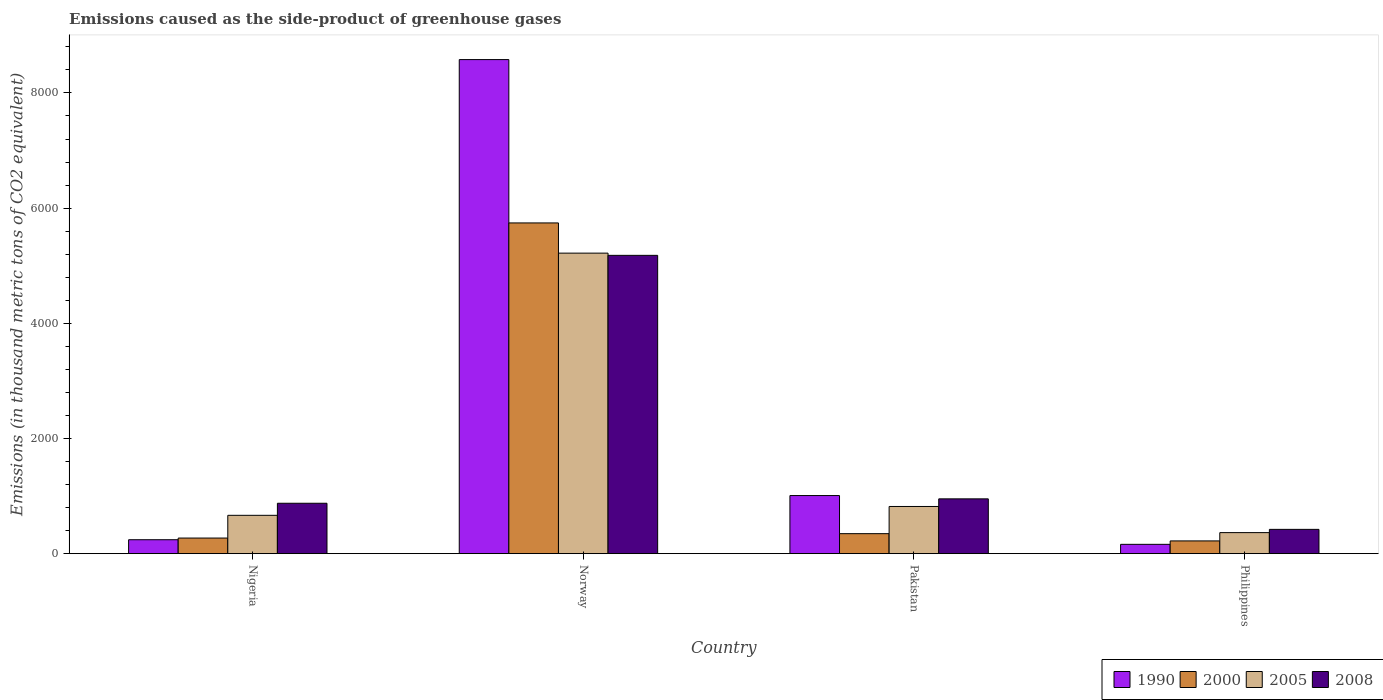Are the number of bars on each tick of the X-axis equal?
Your answer should be compact. Yes. How many bars are there on the 2nd tick from the right?
Offer a terse response. 4. What is the label of the 4th group of bars from the left?
Your answer should be very brief. Philippines. In how many cases, is the number of bars for a given country not equal to the number of legend labels?
Your answer should be compact. 0. What is the emissions caused as the side-product of greenhouse gases in 2000 in Pakistan?
Offer a very short reply. 347.2. Across all countries, what is the maximum emissions caused as the side-product of greenhouse gases in 1990?
Provide a short and direct response. 8579.3. Across all countries, what is the minimum emissions caused as the side-product of greenhouse gases in 2005?
Your response must be concise. 365.3. In which country was the emissions caused as the side-product of greenhouse gases in 1990 maximum?
Keep it short and to the point. Norway. In which country was the emissions caused as the side-product of greenhouse gases in 2000 minimum?
Make the answer very short. Philippines. What is the total emissions caused as the side-product of greenhouse gases in 2005 in the graph?
Offer a very short reply. 7068.9. What is the difference between the emissions caused as the side-product of greenhouse gases in 2005 in Nigeria and that in Philippines?
Give a very brief answer. 300.4. What is the difference between the emissions caused as the side-product of greenhouse gases in 1990 in Pakistan and the emissions caused as the side-product of greenhouse gases in 2008 in Norway?
Offer a very short reply. -4170.9. What is the average emissions caused as the side-product of greenhouse gases in 2005 per country?
Ensure brevity in your answer.  1767.22. What is the difference between the emissions caused as the side-product of greenhouse gases of/in 1990 and emissions caused as the side-product of greenhouse gases of/in 2008 in Norway?
Your response must be concise. 3399.4. What is the ratio of the emissions caused as the side-product of greenhouse gases in 2000 in Norway to that in Pakistan?
Provide a succinct answer. 16.54. Is the emissions caused as the side-product of greenhouse gases in 1990 in Nigeria less than that in Norway?
Give a very brief answer. Yes. What is the difference between the highest and the second highest emissions caused as the side-product of greenhouse gases in 2005?
Provide a short and direct response. -4552.8. What is the difference between the highest and the lowest emissions caused as the side-product of greenhouse gases in 2000?
Offer a very short reply. 5521.4. Is the sum of the emissions caused as the side-product of greenhouse gases in 2005 in Norway and Philippines greater than the maximum emissions caused as the side-product of greenhouse gases in 2008 across all countries?
Provide a succinct answer. Yes. How many bars are there?
Make the answer very short. 16. Are all the bars in the graph horizontal?
Keep it short and to the point. No. What is the difference between two consecutive major ticks on the Y-axis?
Give a very brief answer. 2000. Does the graph contain any zero values?
Make the answer very short. No. Where does the legend appear in the graph?
Your response must be concise. Bottom right. How many legend labels are there?
Provide a short and direct response. 4. What is the title of the graph?
Offer a very short reply. Emissions caused as the side-product of greenhouse gases. Does "1973" appear as one of the legend labels in the graph?
Offer a terse response. No. What is the label or title of the Y-axis?
Make the answer very short. Emissions (in thousand metric tons of CO2 equivalent). What is the Emissions (in thousand metric tons of CO2 equivalent) in 1990 in Nigeria?
Your response must be concise. 241.9. What is the Emissions (in thousand metric tons of CO2 equivalent) of 2000 in Nigeria?
Give a very brief answer. 270.9. What is the Emissions (in thousand metric tons of CO2 equivalent) of 2005 in Nigeria?
Provide a short and direct response. 665.7. What is the Emissions (in thousand metric tons of CO2 equivalent) in 2008 in Nigeria?
Your response must be concise. 875.2. What is the Emissions (in thousand metric tons of CO2 equivalent) of 1990 in Norway?
Offer a very short reply. 8579.3. What is the Emissions (in thousand metric tons of CO2 equivalent) in 2000 in Norway?
Ensure brevity in your answer.  5742.8. What is the Emissions (in thousand metric tons of CO2 equivalent) in 2005 in Norway?
Offer a very short reply. 5218.5. What is the Emissions (in thousand metric tons of CO2 equivalent) of 2008 in Norway?
Make the answer very short. 5179.9. What is the Emissions (in thousand metric tons of CO2 equivalent) in 1990 in Pakistan?
Make the answer very short. 1009. What is the Emissions (in thousand metric tons of CO2 equivalent) of 2000 in Pakistan?
Your answer should be very brief. 347.2. What is the Emissions (in thousand metric tons of CO2 equivalent) of 2005 in Pakistan?
Your answer should be compact. 819.4. What is the Emissions (in thousand metric tons of CO2 equivalent) of 2008 in Pakistan?
Provide a short and direct response. 951.6. What is the Emissions (in thousand metric tons of CO2 equivalent) in 1990 in Philippines?
Give a very brief answer. 161.9. What is the Emissions (in thousand metric tons of CO2 equivalent) in 2000 in Philippines?
Your answer should be very brief. 221.4. What is the Emissions (in thousand metric tons of CO2 equivalent) in 2005 in Philippines?
Your answer should be compact. 365.3. What is the Emissions (in thousand metric tons of CO2 equivalent) of 2008 in Philippines?
Offer a terse response. 421.7. Across all countries, what is the maximum Emissions (in thousand metric tons of CO2 equivalent) of 1990?
Provide a short and direct response. 8579.3. Across all countries, what is the maximum Emissions (in thousand metric tons of CO2 equivalent) in 2000?
Your response must be concise. 5742.8. Across all countries, what is the maximum Emissions (in thousand metric tons of CO2 equivalent) of 2005?
Your answer should be very brief. 5218.5. Across all countries, what is the maximum Emissions (in thousand metric tons of CO2 equivalent) in 2008?
Offer a terse response. 5179.9. Across all countries, what is the minimum Emissions (in thousand metric tons of CO2 equivalent) of 1990?
Give a very brief answer. 161.9. Across all countries, what is the minimum Emissions (in thousand metric tons of CO2 equivalent) in 2000?
Provide a succinct answer. 221.4. Across all countries, what is the minimum Emissions (in thousand metric tons of CO2 equivalent) of 2005?
Provide a succinct answer. 365.3. Across all countries, what is the minimum Emissions (in thousand metric tons of CO2 equivalent) in 2008?
Your answer should be compact. 421.7. What is the total Emissions (in thousand metric tons of CO2 equivalent) in 1990 in the graph?
Your response must be concise. 9992.1. What is the total Emissions (in thousand metric tons of CO2 equivalent) in 2000 in the graph?
Give a very brief answer. 6582.3. What is the total Emissions (in thousand metric tons of CO2 equivalent) of 2005 in the graph?
Provide a short and direct response. 7068.9. What is the total Emissions (in thousand metric tons of CO2 equivalent) of 2008 in the graph?
Your answer should be compact. 7428.4. What is the difference between the Emissions (in thousand metric tons of CO2 equivalent) in 1990 in Nigeria and that in Norway?
Provide a short and direct response. -8337.4. What is the difference between the Emissions (in thousand metric tons of CO2 equivalent) of 2000 in Nigeria and that in Norway?
Your answer should be very brief. -5471.9. What is the difference between the Emissions (in thousand metric tons of CO2 equivalent) in 2005 in Nigeria and that in Norway?
Your answer should be compact. -4552.8. What is the difference between the Emissions (in thousand metric tons of CO2 equivalent) of 2008 in Nigeria and that in Norway?
Provide a succinct answer. -4304.7. What is the difference between the Emissions (in thousand metric tons of CO2 equivalent) of 1990 in Nigeria and that in Pakistan?
Keep it short and to the point. -767.1. What is the difference between the Emissions (in thousand metric tons of CO2 equivalent) of 2000 in Nigeria and that in Pakistan?
Provide a short and direct response. -76.3. What is the difference between the Emissions (in thousand metric tons of CO2 equivalent) in 2005 in Nigeria and that in Pakistan?
Make the answer very short. -153.7. What is the difference between the Emissions (in thousand metric tons of CO2 equivalent) of 2008 in Nigeria and that in Pakistan?
Offer a terse response. -76.4. What is the difference between the Emissions (in thousand metric tons of CO2 equivalent) in 2000 in Nigeria and that in Philippines?
Offer a terse response. 49.5. What is the difference between the Emissions (in thousand metric tons of CO2 equivalent) of 2005 in Nigeria and that in Philippines?
Ensure brevity in your answer.  300.4. What is the difference between the Emissions (in thousand metric tons of CO2 equivalent) in 2008 in Nigeria and that in Philippines?
Your answer should be compact. 453.5. What is the difference between the Emissions (in thousand metric tons of CO2 equivalent) of 1990 in Norway and that in Pakistan?
Keep it short and to the point. 7570.3. What is the difference between the Emissions (in thousand metric tons of CO2 equivalent) of 2000 in Norway and that in Pakistan?
Give a very brief answer. 5395.6. What is the difference between the Emissions (in thousand metric tons of CO2 equivalent) of 2005 in Norway and that in Pakistan?
Provide a succinct answer. 4399.1. What is the difference between the Emissions (in thousand metric tons of CO2 equivalent) in 2008 in Norway and that in Pakistan?
Offer a very short reply. 4228.3. What is the difference between the Emissions (in thousand metric tons of CO2 equivalent) of 1990 in Norway and that in Philippines?
Keep it short and to the point. 8417.4. What is the difference between the Emissions (in thousand metric tons of CO2 equivalent) in 2000 in Norway and that in Philippines?
Give a very brief answer. 5521.4. What is the difference between the Emissions (in thousand metric tons of CO2 equivalent) of 2005 in Norway and that in Philippines?
Give a very brief answer. 4853.2. What is the difference between the Emissions (in thousand metric tons of CO2 equivalent) of 2008 in Norway and that in Philippines?
Make the answer very short. 4758.2. What is the difference between the Emissions (in thousand metric tons of CO2 equivalent) in 1990 in Pakistan and that in Philippines?
Give a very brief answer. 847.1. What is the difference between the Emissions (in thousand metric tons of CO2 equivalent) of 2000 in Pakistan and that in Philippines?
Offer a terse response. 125.8. What is the difference between the Emissions (in thousand metric tons of CO2 equivalent) of 2005 in Pakistan and that in Philippines?
Give a very brief answer. 454.1. What is the difference between the Emissions (in thousand metric tons of CO2 equivalent) in 2008 in Pakistan and that in Philippines?
Your answer should be very brief. 529.9. What is the difference between the Emissions (in thousand metric tons of CO2 equivalent) in 1990 in Nigeria and the Emissions (in thousand metric tons of CO2 equivalent) in 2000 in Norway?
Offer a very short reply. -5500.9. What is the difference between the Emissions (in thousand metric tons of CO2 equivalent) of 1990 in Nigeria and the Emissions (in thousand metric tons of CO2 equivalent) of 2005 in Norway?
Keep it short and to the point. -4976.6. What is the difference between the Emissions (in thousand metric tons of CO2 equivalent) of 1990 in Nigeria and the Emissions (in thousand metric tons of CO2 equivalent) of 2008 in Norway?
Offer a terse response. -4938. What is the difference between the Emissions (in thousand metric tons of CO2 equivalent) of 2000 in Nigeria and the Emissions (in thousand metric tons of CO2 equivalent) of 2005 in Norway?
Offer a very short reply. -4947.6. What is the difference between the Emissions (in thousand metric tons of CO2 equivalent) of 2000 in Nigeria and the Emissions (in thousand metric tons of CO2 equivalent) of 2008 in Norway?
Give a very brief answer. -4909. What is the difference between the Emissions (in thousand metric tons of CO2 equivalent) of 2005 in Nigeria and the Emissions (in thousand metric tons of CO2 equivalent) of 2008 in Norway?
Keep it short and to the point. -4514.2. What is the difference between the Emissions (in thousand metric tons of CO2 equivalent) in 1990 in Nigeria and the Emissions (in thousand metric tons of CO2 equivalent) in 2000 in Pakistan?
Make the answer very short. -105.3. What is the difference between the Emissions (in thousand metric tons of CO2 equivalent) of 1990 in Nigeria and the Emissions (in thousand metric tons of CO2 equivalent) of 2005 in Pakistan?
Keep it short and to the point. -577.5. What is the difference between the Emissions (in thousand metric tons of CO2 equivalent) of 1990 in Nigeria and the Emissions (in thousand metric tons of CO2 equivalent) of 2008 in Pakistan?
Provide a short and direct response. -709.7. What is the difference between the Emissions (in thousand metric tons of CO2 equivalent) of 2000 in Nigeria and the Emissions (in thousand metric tons of CO2 equivalent) of 2005 in Pakistan?
Make the answer very short. -548.5. What is the difference between the Emissions (in thousand metric tons of CO2 equivalent) in 2000 in Nigeria and the Emissions (in thousand metric tons of CO2 equivalent) in 2008 in Pakistan?
Provide a succinct answer. -680.7. What is the difference between the Emissions (in thousand metric tons of CO2 equivalent) in 2005 in Nigeria and the Emissions (in thousand metric tons of CO2 equivalent) in 2008 in Pakistan?
Your response must be concise. -285.9. What is the difference between the Emissions (in thousand metric tons of CO2 equivalent) of 1990 in Nigeria and the Emissions (in thousand metric tons of CO2 equivalent) of 2000 in Philippines?
Provide a short and direct response. 20.5. What is the difference between the Emissions (in thousand metric tons of CO2 equivalent) in 1990 in Nigeria and the Emissions (in thousand metric tons of CO2 equivalent) in 2005 in Philippines?
Your answer should be compact. -123.4. What is the difference between the Emissions (in thousand metric tons of CO2 equivalent) in 1990 in Nigeria and the Emissions (in thousand metric tons of CO2 equivalent) in 2008 in Philippines?
Make the answer very short. -179.8. What is the difference between the Emissions (in thousand metric tons of CO2 equivalent) in 2000 in Nigeria and the Emissions (in thousand metric tons of CO2 equivalent) in 2005 in Philippines?
Give a very brief answer. -94.4. What is the difference between the Emissions (in thousand metric tons of CO2 equivalent) in 2000 in Nigeria and the Emissions (in thousand metric tons of CO2 equivalent) in 2008 in Philippines?
Provide a succinct answer. -150.8. What is the difference between the Emissions (in thousand metric tons of CO2 equivalent) in 2005 in Nigeria and the Emissions (in thousand metric tons of CO2 equivalent) in 2008 in Philippines?
Ensure brevity in your answer.  244. What is the difference between the Emissions (in thousand metric tons of CO2 equivalent) of 1990 in Norway and the Emissions (in thousand metric tons of CO2 equivalent) of 2000 in Pakistan?
Your response must be concise. 8232.1. What is the difference between the Emissions (in thousand metric tons of CO2 equivalent) in 1990 in Norway and the Emissions (in thousand metric tons of CO2 equivalent) in 2005 in Pakistan?
Give a very brief answer. 7759.9. What is the difference between the Emissions (in thousand metric tons of CO2 equivalent) of 1990 in Norway and the Emissions (in thousand metric tons of CO2 equivalent) of 2008 in Pakistan?
Keep it short and to the point. 7627.7. What is the difference between the Emissions (in thousand metric tons of CO2 equivalent) of 2000 in Norway and the Emissions (in thousand metric tons of CO2 equivalent) of 2005 in Pakistan?
Your answer should be compact. 4923.4. What is the difference between the Emissions (in thousand metric tons of CO2 equivalent) in 2000 in Norway and the Emissions (in thousand metric tons of CO2 equivalent) in 2008 in Pakistan?
Offer a very short reply. 4791.2. What is the difference between the Emissions (in thousand metric tons of CO2 equivalent) in 2005 in Norway and the Emissions (in thousand metric tons of CO2 equivalent) in 2008 in Pakistan?
Ensure brevity in your answer.  4266.9. What is the difference between the Emissions (in thousand metric tons of CO2 equivalent) in 1990 in Norway and the Emissions (in thousand metric tons of CO2 equivalent) in 2000 in Philippines?
Your response must be concise. 8357.9. What is the difference between the Emissions (in thousand metric tons of CO2 equivalent) of 1990 in Norway and the Emissions (in thousand metric tons of CO2 equivalent) of 2005 in Philippines?
Give a very brief answer. 8214. What is the difference between the Emissions (in thousand metric tons of CO2 equivalent) in 1990 in Norway and the Emissions (in thousand metric tons of CO2 equivalent) in 2008 in Philippines?
Your answer should be compact. 8157.6. What is the difference between the Emissions (in thousand metric tons of CO2 equivalent) of 2000 in Norway and the Emissions (in thousand metric tons of CO2 equivalent) of 2005 in Philippines?
Your answer should be very brief. 5377.5. What is the difference between the Emissions (in thousand metric tons of CO2 equivalent) in 2000 in Norway and the Emissions (in thousand metric tons of CO2 equivalent) in 2008 in Philippines?
Keep it short and to the point. 5321.1. What is the difference between the Emissions (in thousand metric tons of CO2 equivalent) of 2005 in Norway and the Emissions (in thousand metric tons of CO2 equivalent) of 2008 in Philippines?
Ensure brevity in your answer.  4796.8. What is the difference between the Emissions (in thousand metric tons of CO2 equivalent) of 1990 in Pakistan and the Emissions (in thousand metric tons of CO2 equivalent) of 2000 in Philippines?
Offer a very short reply. 787.6. What is the difference between the Emissions (in thousand metric tons of CO2 equivalent) in 1990 in Pakistan and the Emissions (in thousand metric tons of CO2 equivalent) in 2005 in Philippines?
Your response must be concise. 643.7. What is the difference between the Emissions (in thousand metric tons of CO2 equivalent) of 1990 in Pakistan and the Emissions (in thousand metric tons of CO2 equivalent) of 2008 in Philippines?
Your answer should be very brief. 587.3. What is the difference between the Emissions (in thousand metric tons of CO2 equivalent) in 2000 in Pakistan and the Emissions (in thousand metric tons of CO2 equivalent) in 2005 in Philippines?
Give a very brief answer. -18.1. What is the difference between the Emissions (in thousand metric tons of CO2 equivalent) in 2000 in Pakistan and the Emissions (in thousand metric tons of CO2 equivalent) in 2008 in Philippines?
Your response must be concise. -74.5. What is the difference between the Emissions (in thousand metric tons of CO2 equivalent) in 2005 in Pakistan and the Emissions (in thousand metric tons of CO2 equivalent) in 2008 in Philippines?
Offer a terse response. 397.7. What is the average Emissions (in thousand metric tons of CO2 equivalent) in 1990 per country?
Ensure brevity in your answer.  2498.03. What is the average Emissions (in thousand metric tons of CO2 equivalent) of 2000 per country?
Offer a terse response. 1645.58. What is the average Emissions (in thousand metric tons of CO2 equivalent) in 2005 per country?
Make the answer very short. 1767.22. What is the average Emissions (in thousand metric tons of CO2 equivalent) in 2008 per country?
Your answer should be compact. 1857.1. What is the difference between the Emissions (in thousand metric tons of CO2 equivalent) in 1990 and Emissions (in thousand metric tons of CO2 equivalent) in 2005 in Nigeria?
Provide a succinct answer. -423.8. What is the difference between the Emissions (in thousand metric tons of CO2 equivalent) in 1990 and Emissions (in thousand metric tons of CO2 equivalent) in 2008 in Nigeria?
Make the answer very short. -633.3. What is the difference between the Emissions (in thousand metric tons of CO2 equivalent) of 2000 and Emissions (in thousand metric tons of CO2 equivalent) of 2005 in Nigeria?
Your answer should be compact. -394.8. What is the difference between the Emissions (in thousand metric tons of CO2 equivalent) of 2000 and Emissions (in thousand metric tons of CO2 equivalent) of 2008 in Nigeria?
Offer a terse response. -604.3. What is the difference between the Emissions (in thousand metric tons of CO2 equivalent) of 2005 and Emissions (in thousand metric tons of CO2 equivalent) of 2008 in Nigeria?
Give a very brief answer. -209.5. What is the difference between the Emissions (in thousand metric tons of CO2 equivalent) of 1990 and Emissions (in thousand metric tons of CO2 equivalent) of 2000 in Norway?
Give a very brief answer. 2836.5. What is the difference between the Emissions (in thousand metric tons of CO2 equivalent) in 1990 and Emissions (in thousand metric tons of CO2 equivalent) in 2005 in Norway?
Offer a terse response. 3360.8. What is the difference between the Emissions (in thousand metric tons of CO2 equivalent) in 1990 and Emissions (in thousand metric tons of CO2 equivalent) in 2008 in Norway?
Offer a very short reply. 3399.4. What is the difference between the Emissions (in thousand metric tons of CO2 equivalent) in 2000 and Emissions (in thousand metric tons of CO2 equivalent) in 2005 in Norway?
Your answer should be very brief. 524.3. What is the difference between the Emissions (in thousand metric tons of CO2 equivalent) in 2000 and Emissions (in thousand metric tons of CO2 equivalent) in 2008 in Norway?
Your answer should be very brief. 562.9. What is the difference between the Emissions (in thousand metric tons of CO2 equivalent) of 2005 and Emissions (in thousand metric tons of CO2 equivalent) of 2008 in Norway?
Offer a terse response. 38.6. What is the difference between the Emissions (in thousand metric tons of CO2 equivalent) in 1990 and Emissions (in thousand metric tons of CO2 equivalent) in 2000 in Pakistan?
Your answer should be very brief. 661.8. What is the difference between the Emissions (in thousand metric tons of CO2 equivalent) of 1990 and Emissions (in thousand metric tons of CO2 equivalent) of 2005 in Pakistan?
Make the answer very short. 189.6. What is the difference between the Emissions (in thousand metric tons of CO2 equivalent) of 1990 and Emissions (in thousand metric tons of CO2 equivalent) of 2008 in Pakistan?
Offer a very short reply. 57.4. What is the difference between the Emissions (in thousand metric tons of CO2 equivalent) of 2000 and Emissions (in thousand metric tons of CO2 equivalent) of 2005 in Pakistan?
Provide a succinct answer. -472.2. What is the difference between the Emissions (in thousand metric tons of CO2 equivalent) in 2000 and Emissions (in thousand metric tons of CO2 equivalent) in 2008 in Pakistan?
Offer a very short reply. -604.4. What is the difference between the Emissions (in thousand metric tons of CO2 equivalent) of 2005 and Emissions (in thousand metric tons of CO2 equivalent) of 2008 in Pakistan?
Your response must be concise. -132.2. What is the difference between the Emissions (in thousand metric tons of CO2 equivalent) of 1990 and Emissions (in thousand metric tons of CO2 equivalent) of 2000 in Philippines?
Ensure brevity in your answer.  -59.5. What is the difference between the Emissions (in thousand metric tons of CO2 equivalent) in 1990 and Emissions (in thousand metric tons of CO2 equivalent) in 2005 in Philippines?
Offer a very short reply. -203.4. What is the difference between the Emissions (in thousand metric tons of CO2 equivalent) of 1990 and Emissions (in thousand metric tons of CO2 equivalent) of 2008 in Philippines?
Ensure brevity in your answer.  -259.8. What is the difference between the Emissions (in thousand metric tons of CO2 equivalent) of 2000 and Emissions (in thousand metric tons of CO2 equivalent) of 2005 in Philippines?
Make the answer very short. -143.9. What is the difference between the Emissions (in thousand metric tons of CO2 equivalent) of 2000 and Emissions (in thousand metric tons of CO2 equivalent) of 2008 in Philippines?
Offer a terse response. -200.3. What is the difference between the Emissions (in thousand metric tons of CO2 equivalent) in 2005 and Emissions (in thousand metric tons of CO2 equivalent) in 2008 in Philippines?
Keep it short and to the point. -56.4. What is the ratio of the Emissions (in thousand metric tons of CO2 equivalent) of 1990 in Nigeria to that in Norway?
Your answer should be compact. 0.03. What is the ratio of the Emissions (in thousand metric tons of CO2 equivalent) in 2000 in Nigeria to that in Norway?
Your answer should be compact. 0.05. What is the ratio of the Emissions (in thousand metric tons of CO2 equivalent) of 2005 in Nigeria to that in Norway?
Your response must be concise. 0.13. What is the ratio of the Emissions (in thousand metric tons of CO2 equivalent) of 2008 in Nigeria to that in Norway?
Offer a very short reply. 0.17. What is the ratio of the Emissions (in thousand metric tons of CO2 equivalent) of 1990 in Nigeria to that in Pakistan?
Offer a terse response. 0.24. What is the ratio of the Emissions (in thousand metric tons of CO2 equivalent) in 2000 in Nigeria to that in Pakistan?
Your answer should be very brief. 0.78. What is the ratio of the Emissions (in thousand metric tons of CO2 equivalent) in 2005 in Nigeria to that in Pakistan?
Your answer should be very brief. 0.81. What is the ratio of the Emissions (in thousand metric tons of CO2 equivalent) in 2008 in Nigeria to that in Pakistan?
Give a very brief answer. 0.92. What is the ratio of the Emissions (in thousand metric tons of CO2 equivalent) in 1990 in Nigeria to that in Philippines?
Provide a succinct answer. 1.49. What is the ratio of the Emissions (in thousand metric tons of CO2 equivalent) of 2000 in Nigeria to that in Philippines?
Make the answer very short. 1.22. What is the ratio of the Emissions (in thousand metric tons of CO2 equivalent) of 2005 in Nigeria to that in Philippines?
Your answer should be very brief. 1.82. What is the ratio of the Emissions (in thousand metric tons of CO2 equivalent) in 2008 in Nigeria to that in Philippines?
Your answer should be compact. 2.08. What is the ratio of the Emissions (in thousand metric tons of CO2 equivalent) of 1990 in Norway to that in Pakistan?
Give a very brief answer. 8.5. What is the ratio of the Emissions (in thousand metric tons of CO2 equivalent) of 2000 in Norway to that in Pakistan?
Your answer should be very brief. 16.54. What is the ratio of the Emissions (in thousand metric tons of CO2 equivalent) of 2005 in Norway to that in Pakistan?
Give a very brief answer. 6.37. What is the ratio of the Emissions (in thousand metric tons of CO2 equivalent) of 2008 in Norway to that in Pakistan?
Your answer should be very brief. 5.44. What is the ratio of the Emissions (in thousand metric tons of CO2 equivalent) in 1990 in Norway to that in Philippines?
Offer a very short reply. 52.99. What is the ratio of the Emissions (in thousand metric tons of CO2 equivalent) of 2000 in Norway to that in Philippines?
Give a very brief answer. 25.94. What is the ratio of the Emissions (in thousand metric tons of CO2 equivalent) of 2005 in Norway to that in Philippines?
Provide a short and direct response. 14.29. What is the ratio of the Emissions (in thousand metric tons of CO2 equivalent) of 2008 in Norway to that in Philippines?
Make the answer very short. 12.28. What is the ratio of the Emissions (in thousand metric tons of CO2 equivalent) in 1990 in Pakistan to that in Philippines?
Keep it short and to the point. 6.23. What is the ratio of the Emissions (in thousand metric tons of CO2 equivalent) of 2000 in Pakistan to that in Philippines?
Ensure brevity in your answer.  1.57. What is the ratio of the Emissions (in thousand metric tons of CO2 equivalent) in 2005 in Pakistan to that in Philippines?
Provide a succinct answer. 2.24. What is the ratio of the Emissions (in thousand metric tons of CO2 equivalent) of 2008 in Pakistan to that in Philippines?
Make the answer very short. 2.26. What is the difference between the highest and the second highest Emissions (in thousand metric tons of CO2 equivalent) in 1990?
Your answer should be compact. 7570.3. What is the difference between the highest and the second highest Emissions (in thousand metric tons of CO2 equivalent) in 2000?
Give a very brief answer. 5395.6. What is the difference between the highest and the second highest Emissions (in thousand metric tons of CO2 equivalent) in 2005?
Your answer should be compact. 4399.1. What is the difference between the highest and the second highest Emissions (in thousand metric tons of CO2 equivalent) of 2008?
Provide a short and direct response. 4228.3. What is the difference between the highest and the lowest Emissions (in thousand metric tons of CO2 equivalent) of 1990?
Your answer should be very brief. 8417.4. What is the difference between the highest and the lowest Emissions (in thousand metric tons of CO2 equivalent) in 2000?
Your answer should be compact. 5521.4. What is the difference between the highest and the lowest Emissions (in thousand metric tons of CO2 equivalent) in 2005?
Offer a terse response. 4853.2. What is the difference between the highest and the lowest Emissions (in thousand metric tons of CO2 equivalent) in 2008?
Offer a terse response. 4758.2. 